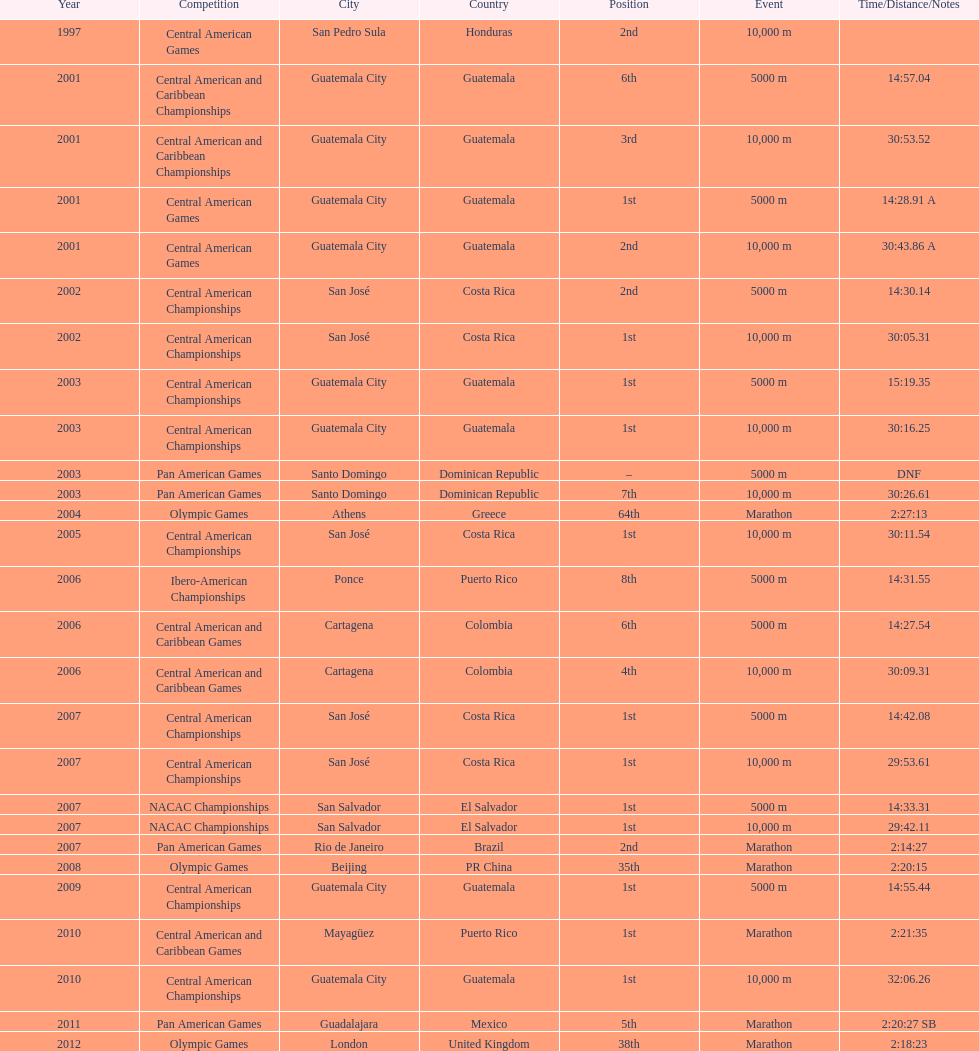What competition did this competitor compete at after participating in the central american games in 2001? Central American Championships. 